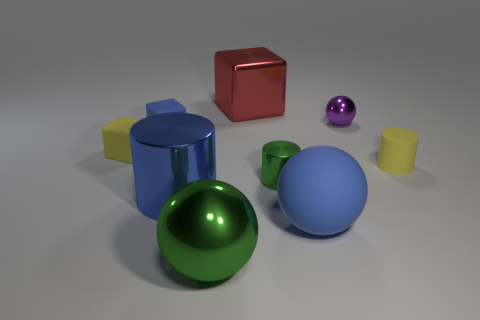There is a yellow matte object that is the same shape as the small blue rubber object; what size is it?
Ensure brevity in your answer.  Small. What material is the sphere to the left of the small thing that is in front of the small matte object that is to the right of the large green object?
Offer a terse response. Metal. Are any large gray shiny cylinders visible?
Provide a short and direct response. No. Does the big metal cylinder have the same color as the sphere on the right side of the rubber ball?
Make the answer very short. No. The big cube has what color?
Your answer should be compact. Red. The other small rubber thing that is the same shape as the small green thing is what color?
Ensure brevity in your answer.  Yellow. Does the blue shiny object have the same shape as the small green metallic object?
Provide a succinct answer. Yes. How many cubes are big blue matte things or yellow things?
Your answer should be very brief. 1. There is a small cylinder that is the same material as the red cube; what is its color?
Offer a terse response. Green. There is a shiny ball right of the red object; is its size the same as the tiny matte cylinder?
Your response must be concise. Yes. 